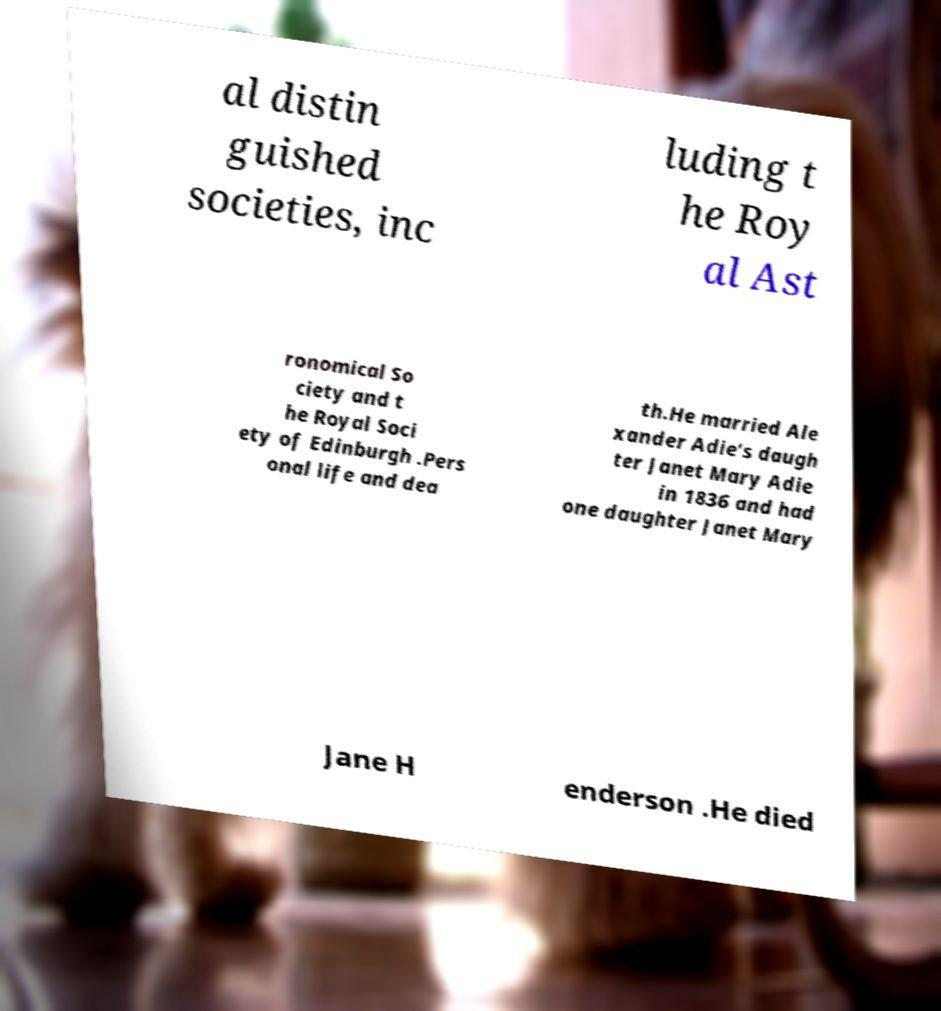Please read and relay the text visible in this image. What does it say? al distin guished societies, inc luding t he Roy al Ast ronomical So ciety and t he Royal Soci ety of Edinburgh .Pers onal life and dea th.He married Ale xander Adie's daugh ter Janet Mary Adie in 1836 and had one daughter Janet Mary Jane H enderson .He died 